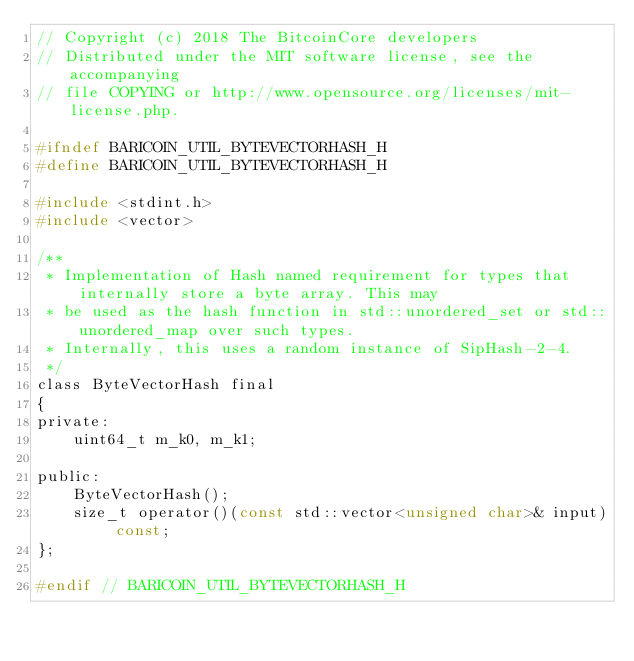Convert code to text. <code><loc_0><loc_0><loc_500><loc_500><_C_>// Copyright (c) 2018 The BitcoinCore developers
// Distributed under the MIT software license, see the accompanying
// file COPYING or http://www.opensource.org/licenses/mit-license.php.

#ifndef BARICOIN_UTIL_BYTEVECTORHASH_H
#define BARICOIN_UTIL_BYTEVECTORHASH_H

#include <stdint.h>
#include <vector>

/**
 * Implementation of Hash named requirement for types that internally store a byte array. This may
 * be used as the hash function in std::unordered_set or std::unordered_map over such types.
 * Internally, this uses a random instance of SipHash-2-4.
 */
class ByteVectorHash final
{
private:
    uint64_t m_k0, m_k1;

public:
    ByteVectorHash();
    size_t operator()(const std::vector<unsigned char>& input) const;
};

#endif // BARICOIN_UTIL_BYTEVECTORHASH_H
</code> 